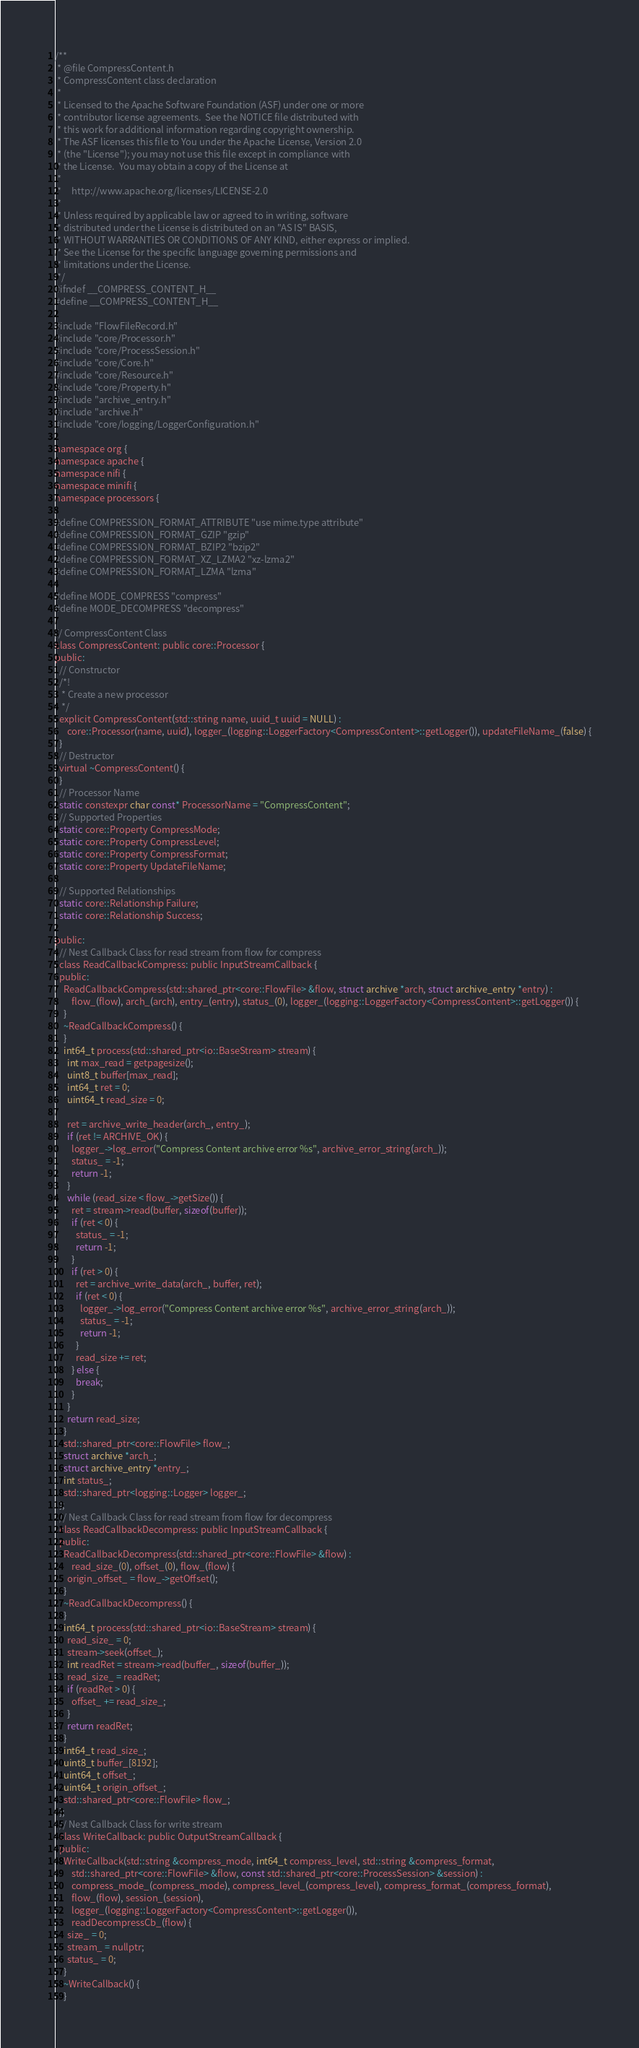Convert code to text. <code><loc_0><loc_0><loc_500><loc_500><_C_>/**
 * @file CompressContent.h
 * CompressContent class declaration
 *
 * Licensed to the Apache Software Foundation (ASF) under one or more
 * contributor license agreements.  See the NOTICE file distributed with
 * this work for additional information regarding copyright ownership.
 * The ASF licenses this file to You under the Apache License, Version 2.0
 * (the "License"); you may not use this file except in compliance with
 * the License.  You may obtain a copy of the License at
 *
 *     http://www.apache.org/licenses/LICENSE-2.0
 *
 * Unless required by applicable law or agreed to in writing, software
 * distributed under the License is distributed on an "AS IS" BASIS,
 * WITHOUT WARRANTIES OR CONDITIONS OF ANY KIND, either express or implied.
 * See the License for the specific language governing permissions and
 * limitations under the License.
 */
#ifndef __COMPRESS_CONTENT_H__
#define __COMPRESS_CONTENT_H__

#include "FlowFileRecord.h"
#include "core/Processor.h"
#include "core/ProcessSession.h"
#include "core/Core.h"
#include "core/Resource.h"
#include "core/Property.h"
#include "archive_entry.h"
#include "archive.h"
#include "core/logging/LoggerConfiguration.h"

namespace org {
namespace apache {
namespace nifi {
namespace minifi {
namespace processors {

#define COMPRESSION_FORMAT_ATTRIBUTE "use mime.type attribute"
#define COMPRESSION_FORMAT_GZIP "gzip"
#define COMPRESSION_FORMAT_BZIP2 "bzip2"
#define COMPRESSION_FORMAT_XZ_LZMA2 "xz-lzma2"
#define COMPRESSION_FORMAT_LZMA "lzma"

#define MODE_COMPRESS "compress"
#define MODE_DECOMPRESS "decompress"

// CompressContent Class
class CompressContent: public core::Processor {
public:
  // Constructor
  /*!
   * Create a new processor
   */
  explicit CompressContent(std::string name, uuid_t uuid = NULL) :
      core::Processor(name, uuid), logger_(logging::LoggerFactory<CompressContent>::getLogger()), updateFileName_(false) {
  }
  // Destructor
  virtual ~CompressContent() {
  }
  // Processor Name
  static constexpr char const* ProcessorName = "CompressContent";
  // Supported Properties
  static core::Property CompressMode;
  static core::Property CompressLevel;
  static core::Property CompressFormat;
  static core::Property UpdateFileName;

  // Supported Relationships
  static core::Relationship Failure;
  static core::Relationship Success;

public:
  // Nest Callback Class for read stream from flow for compress
  class ReadCallbackCompress: public InputStreamCallback {
  public:
    ReadCallbackCompress(std::shared_ptr<core::FlowFile> &flow, struct archive *arch, struct archive_entry *entry) :
        flow_(flow), arch_(arch), entry_(entry), status_(0), logger_(logging::LoggerFactory<CompressContent>::getLogger()) {
    }
    ~ReadCallbackCompress() {
    }
    int64_t process(std::shared_ptr<io::BaseStream> stream) {
      int max_read = getpagesize();
      uint8_t buffer[max_read];
      int64_t ret = 0;
      uint64_t read_size = 0;

      ret = archive_write_header(arch_, entry_);
      if (ret != ARCHIVE_OK) {
        logger_->log_error("Compress Content archive error %s", archive_error_string(arch_));
        status_ = -1;
        return -1;
      }
      while (read_size < flow_->getSize()) {
        ret = stream->read(buffer, sizeof(buffer));
        if (ret < 0) {
          status_ = -1;
          return -1;
        }
        if (ret > 0) {
          ret = archive_write_data(arch_, buffer, ret);
          if (ret < 0) {
            logger_->log_error("Compress Content archive error %s", archive_error_string(arch_));
            status_ = -1;
            return -1;
          }
          read_size += ret;
        } else {
          break;
        }
      }
      return read_size;
    }
    std::shared_ptr<core::FlowFile> flow_;
    struct archive *arch_;
    struct archive_entry *entry_;
    int status_;
    std::shared_ptr<logging::Logger> logger_;
  };
  // Nest Callback Class for read stream from flow for decompress
  class ReadCallbackDecompress: public InputStreamCallback {
  public:
    ReadCallbackDecompress(std::shared_ptr<core::FlowFile> &flow) :
        read_size_(0), offset_(0), flow_(flow) {
      origin_offset_ = flow_->getOffset();
    }
    ~ReadCallbackDecompress() {
    }
    int64_t process(std::shared_ptr<io::BaseStream> stream) {
      read_size_ = 0;
      stream->seek(offset_);
      int readRet = stream->read(buffer_, sizeof(buffer_));
      read_size_ = readRet;
      if (readRet > 0) {
        offset_ += read_size_;
      }
      return readRet;
    }
    int64_t read_size_;
    uint8_t buffer_[8192];
    uint64_t offset_;
    uint64_t origin_offset_;
    std::shared_ptr<core::FlowFile> flow_;
  };
  // Nest Callback Class for write stream
  class WriteCallback: public OutputStreamCallback {
  public:
    WriteCallback(std::string &compress_mode, int64_t compress_level, std::string &compress_format,
        std::shared_ptr<core::FlowFile> &flow, const std::shared_ptr<core::ProcessSession> &session) :
        compress_mode_(compress_mode), compress_level_(compress_level), compress_format_(compress_format),
        flow_(flow), session_(session),
        logger_(logging::LoggerFactory<CompressContent>::getLogger()),
        readDecompressCb_(flow) {
      size_ = 0;
      stream_ = nullptr;
      status_ = 0;
    }
    ~WriteCallback() {
    }
</code> 